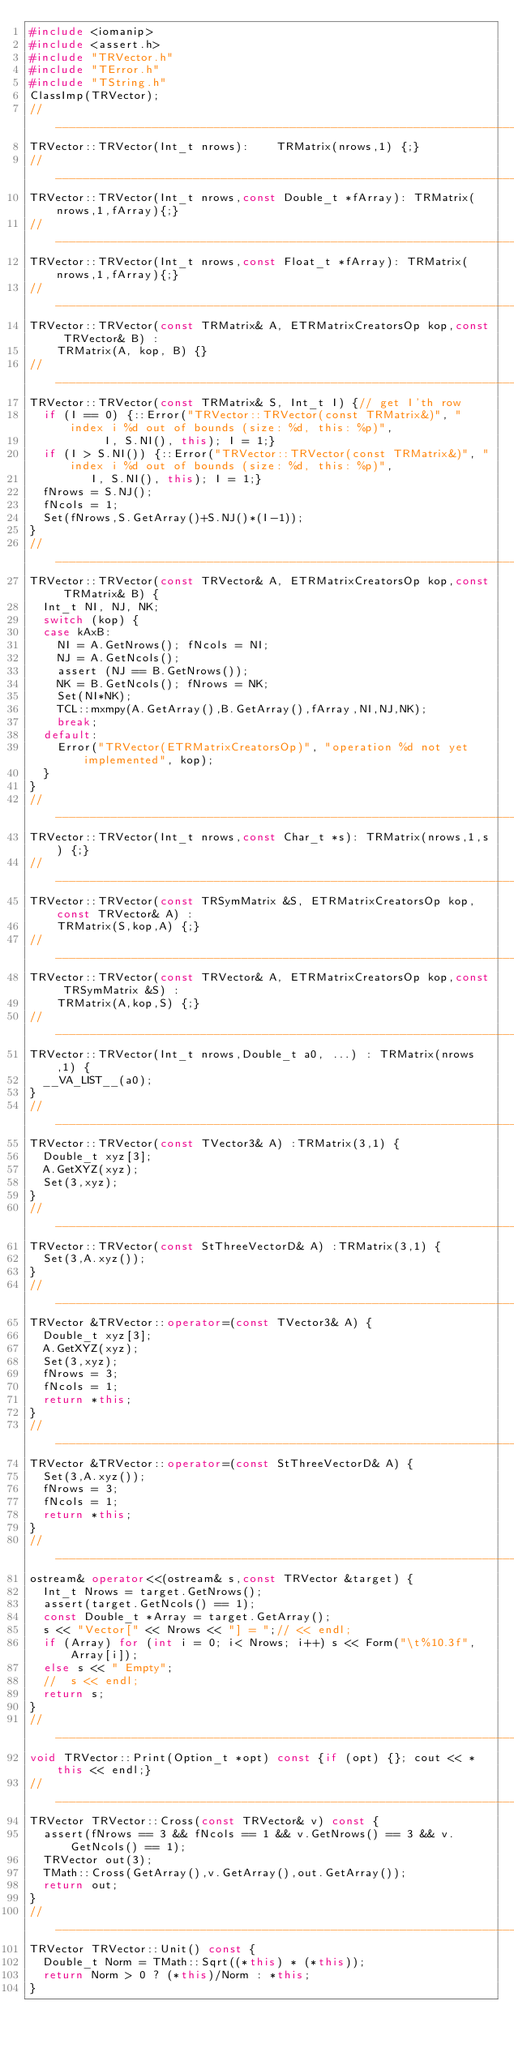<code> <loc_0><loc_0><loc_500><loc_500><_C++_>#include <iomanip>
#include <assert.h>
#include "TRVector.h"
#include "TError.h"
#include "TString.h"
ClassImp(TRVector);
//________________________________________________________________________________
TRVector::TRVector(Int_t nrows):    TRMatrix(nrows,1) {;}
//________________________________________________________________________________
TRVector::TRVector(Int_t nrows,const Double_t *fArray): TRMatrix(nrows,1,fArray){;}
//________________________________________________________________________________
TRVector::TRVector(Int_t nrows,const Float_t *fArray): TRMatrix(nrows,1,fArray){;}
//________________________________________________________________________________
TRVector::TRVector(const TRMatrix& A, ETRMatrixCreatorsOp kop,const TRVector& B) :
    TRMatrix(A, kop, B) {}
//________________________________________________________________________________
TRVector::TRVector(const TRMatrix& S, Int_t I) {// get I'th row
  if (I == 0) {::Error("TRVector::TRVector(const TRMatrix&)", "index i %d out of bounds (size: %d, this: %p)", 
		       I, S.NI(), this); I = 1;}
  if (I > S.NI()) {::Error("TRVector::TRVector(const TRMatrix&)", "index i %d out of bounds (size: %d, this: %p)", 
			   I, S.NI(), this); I = 1;}
  fNrows = S.NJ();
  fNcols = 1;
  Set(fNrows,S.GetArray()+S.NJ()*(I-1));
}
//________________________________________________________________________________
TRVector::TRVector(const TRVector& A, ETRMatrixCreatorsOp kop,const TRMatrix& B) {
  Int_t NI, NJ, NK;
  switch (kop) {
  case kAxB:
    NI = A.GetNrows(); fNcols = NI;
    NJ = A.GetNcols();
    assert (NJ == B.GetNrows());
    NK = B.GetNcols(); fNrows = NK;
    Set(NI*NK);
    TCL::mxmpy(A.GetArray(),B.GetArray(),fArray,NI,NJ,NK);
    break;
  default:
    Error("TRVector(ETRMatrixCreatorsOp)", "operation %d not yet implemented", kop);
  }
}
//________________________________________________________________________________
TRVector::TRVector(Int_t nrows,const Char_t *s): TRMatrix(nrows,1,s) {;}
//________________________________________________________________________________
TRVector::TRVector(const TRSymMatrix &S, ETRMatrixCreatorsOp kop,const TRVector& A) :
    TRMatrix(S,kop,A) {;}
//________________________________________________________________________________
TRVector::TRVector(const TRVector& A, ETRMatrixCreatorsOp kop,const TRSymMatrix &S) :
    TRMatrix(A,kop,S) {;}
//________________________________________________________________________________
TRVector::TRVector(Int_t nrows,Double_t a0, ...) : TRMatrix(nrows,1) {
  __VA_LIST__(a0);
} 
//________________________________________________________________________________
TRVector::TRVector(const TVector3& A) :TRMatrix(3,1) {
  Double_t xyz[3];
  A.GetXYZ(xyz);
  Set(3,xyz);
}
//________________________________________________________________________________
TRVector::TRVector(const StThreeVectorD& A) :TRMatrix(3,1) {
  Set(3,A.xyz());
}
//________________________________________________________________________________
TRVector &TRVector::operator=(const TVector3& A) {
  Double_t xyz[3];
  A.GetXYZ(xyz);
  Set(3,xyz);
  fNrows = 3;
  fNcols = 1;
  return *this;
}
//________________________________________________________________________________
TRVector &TRVector::operator=(const StThreeVectorD& A) {
  Set(3,A.xyz());
  fNrows = 3;
  fNcols = 1;
  return *this;
}
//________________________________________________________________________________
ostream& operator<<(ostream& s,const TRVector &target) {
  Int_t Nrows = target.GetNrows();
  assert(target.GetNcols() == 1);
  const Double_t *Array = target.GetArray();
  s << "Vector[" << Nrows << "] = ";// << endl;
  if (Array) for (int i = 0; i< Nrows; i++) s << Form("\t%10.3f",Array[i]);
  else s << " Empty";
  //  s << endl;
  return s;
}
//________________________________________________________________________________
void TRVector::Print(Option_t *opt) const {if (opt) {}; cout << *this << endl;}
//________________________________________________________________________________
TRVector TRVector::Cross(const TRVector& v) const {
  assert(fNrows == 3 && fNcols == 1 && v.GetNrows() == 3 && v.GetNcols() == 1);
  TRVector out(3);
  TMath::Cross(GetArray(),v.GetArray(),out.GetArray());
  return out;
}
//________________________________________________________________________________
TRVector TRVector::Unit() const {
  Double_t Norm = TMath::Sqrt((*this) * (*this));
  return Norm > 0 ? (*this)/Norm : *this;
}
</code> 